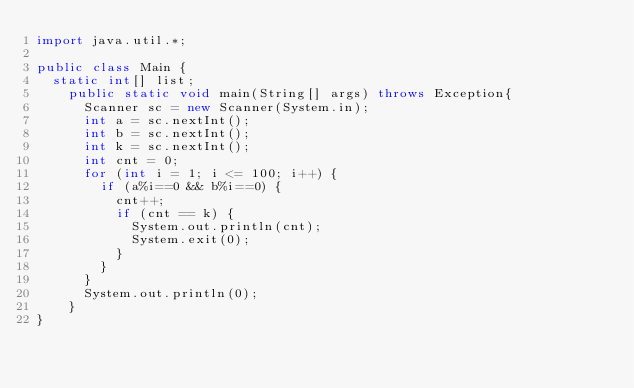Convert code to text. <code><loc_0><loc_0><loc_500><loc_500><_Java_>import java.util.*;

public class Main {
  static int[] list;
    public static void main(String[] args) throws Exception{
      Scanner sc = new Scanner(System.in);
      int a = sc.nextInt();
      int b = sc.nextInt();
      int k = sc.nextInt();
      int cnt = 0;
      for (int i = 1; i <= 100; i++) {
        if (a%i==0 && b%i==0) {
          cnt++;
          if (cnt == k) {
            System.out.println(cnt);
            System.exit(0);
          }
        }
      }
      System.out.println(0);
    }
}</code> 